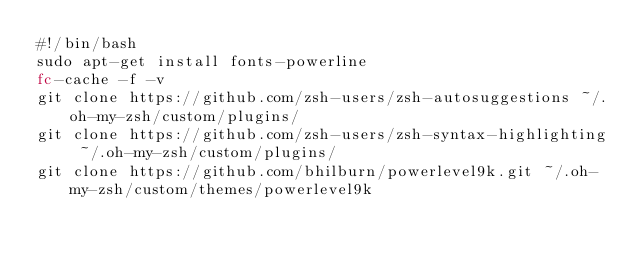<code> <loc_0><loc_0><loc_500><loc_500><_Bash_>#!/bin/bash
sudo apt-get install fonts-powerline
fc-cache -f -v
git clone https://github.com/zsh-users/zsh-autosuggestions ~/.oh-my-zsh/custom/plugins/
git clone https://github.com/zsh-users/zsh-syntax-highlighting ~/.oh-my-zsh/custom/plugins/
git clone https://github.com/bhilburn/powerlevel9k.git ~/.oh-my-zsh/custom/themes/powerlevel9k
</code> 